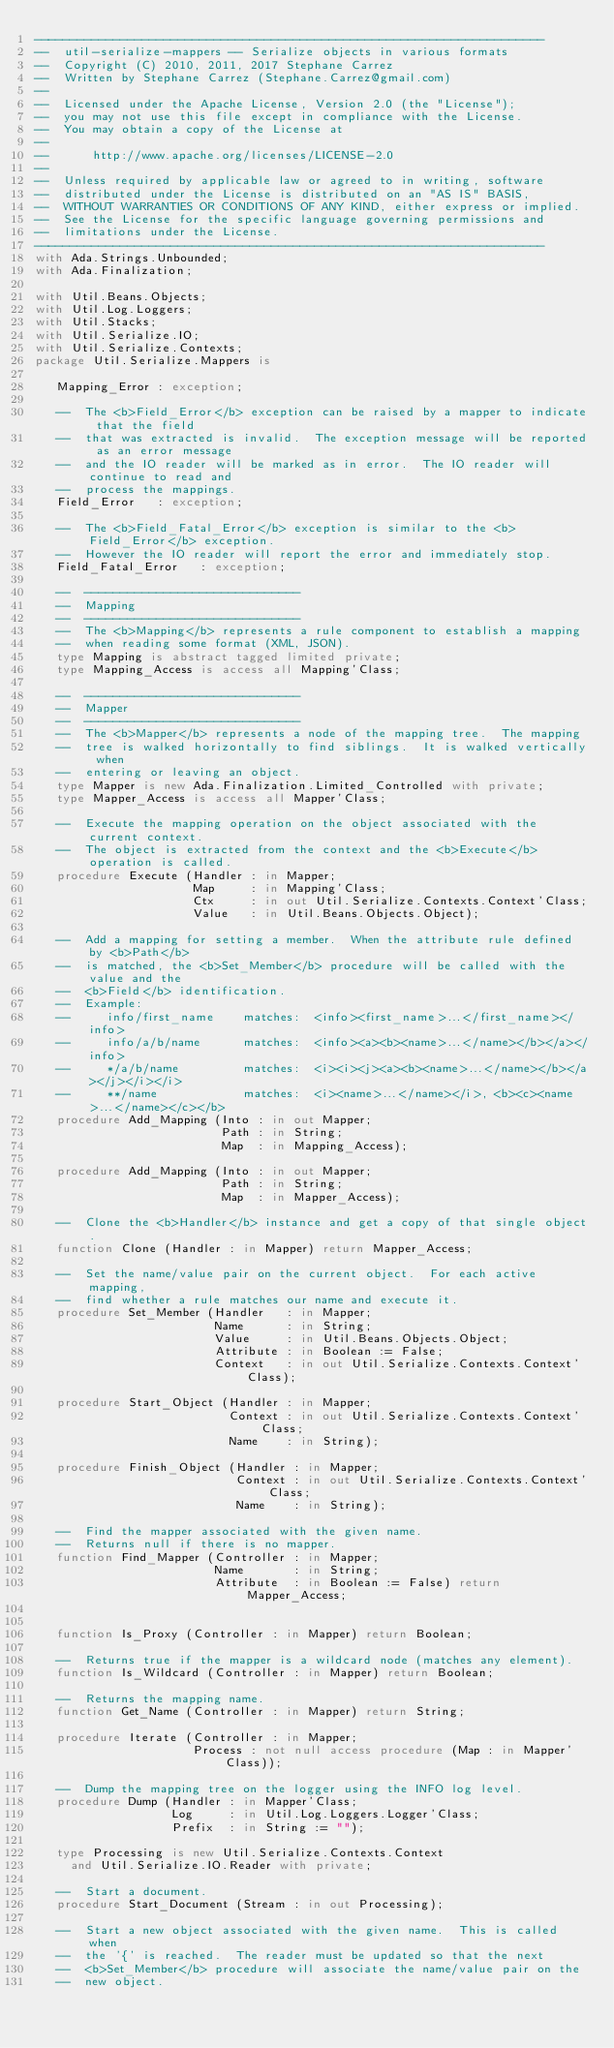<code> <loc_0><loc_0><loc_500><loc_500><_Ada_>-----------------------------------------------------------------------
--  util-serialize-mappers -- Serialize objects in various formats
--  Copyright (C) 2010, 2011, 2017 Stephane Carrez
--  Written by Stephane Carrez (Stephane.Carrez@gmail.com)
--
--  Licensed under the Apache License, Version 2.0 (the "License");
--  you may not use this file except in compliance with the License.
--  You may obtain a copy of the License at
--
--      http://www.apache.org/licenses/LICENSE-2.0
--
--  Unless required by applicable law or agreed to in writing, software
--  distributed under the License is distributed on an "AS IS" BASIS,
--  WITHOUT WARRANTIES OR CONDITIONS OF ANY KIND, either express or implied.
--  See the License for the specific language governing permissions and
--  limitations under the License.
-----------------------------------------------------------------------
with Ada.Strings.Unbounded;
with Ada.Finalization;

with Util.Beans.Objects;
with Util.Log.Loggers;
with Util.Stacks;
with Util.Serialize.IO;
with Util.Serialize.Contexts;
package Util.Serialize.Mappers is

   Mapping_Error : exception;

   --  The <b>Field_Error</b> exception can be raised by a mapper to indicate that the field
   --  that was extracted is invalid.  The exception message will be reported as an error message
   --  and the IO reader will be marked as in error.  The IO reader will continue to read and
   --  process the mappings.
   Field_Error   : exception;

   --  The <b>Field_Fatal_Error</b> exception is similar to the <b>Field_Error</b> exception.
   --  However the IO reader will report the error and immediately stop.
   Field_Fatal_Error   : exception;

   --  ------------------------------
   --  Mapping
   --  ------------------------------
   --  The <b>Mapping</b> represents a rule component to establish a mapping
   --  when reading some format (XML, JSON).
   type Mapping is abstract tagged limited private;
   type Mapping_Access is access all Mapping'Class;

   --  ------------------------------
   --  Mapper
   --  ------------------------------
   --  The <b>Mapper</b> represents a node of the mapping tree.  The mapping
   --  tree is walked horizontally to find siblings.  It is walked vertically when
   --  entering or leaving an object.
   type Mapper is new Ada.Finalization.Limited_Controlled with private;
   type Mapper_Access is access all Mapper'Class;

   --  Execute the mapping operation on the object associated with the current context.
   --  The object is extracted from the context and the <b>Execute</b> operation is called.
   procedure Execute (Handler : in Mapper;
                      Map     : in Mapping'Class;
                      Ctx     : in out Util.Serialize.Contexts.Context'Class;
                      Value   : in Util.Beans.Objects.Object);

   --  Add a mapping for setting a member.  When the attribute rule defined by <b>Path</b>
   --  is matched, the <b>Set_Member</b> procedure will be called with the value and the
   --  <b>Field</b> identification.
   --  Example:
   --     info/first_name    matches:  <info><first_name>...</first_name></info>
   --     info/a/b/name      matches:  <info><a><b><name>...</name></b></a></info>
   --     */a/b/name         matches:  <i><i><j><a><b><name>...</name></b></a></j></i></i>
   --     **/name            matches:  <i><name>...</name></i>, <b><c><name>...</name></c></b>
   procedure Add_Mapping (Into : in out Mapper;
                          Path : in String;
                          Map  : in Mapping_Access);

   procedure Add_Mapping (Into : in out Mapper;
                          Path : in String;
                          Map  : in Mapper_Access);

   --  Clone the <b>Handler</b> instance and get a copy of that single object.
   function Clone (Handler : in Mapper) return Mapper_Access;

   --  Set the name/value pair on the current object.  For each active mapping,
   --  find whether a rule matches our name and execute it.
   procedure Set_Member (Handler   : in Mapper;
                         Name      : in String;
                         Value     : in Util.Beans.Objects.Object;
                         Attribute : in Boolean := False;
                         Context   : in out Util.Serialize.Contexts.Context'Class);

   procedure Start_Object (Handler : in Mapper;
                           Context : in out Util.Serialize.Contexts.Context'Class;
                           Name    : in String);

   procedure Finish_Object (Handler : in Mapper;
                            Context : in out Util.Serialize.Contexts.Context'Class;
                            Name    : in String);

   --  Find the mapper associated with the given name.
   --  Returns null if there is no mapper.
   function Find_Mapper (Controller : in Mapper;
                         Name       : in String;
                         Attribute  : in Boolean := False) return Mapper_Access;


   function Is_Proxy (Controller : in Mapper) return Boolean;

   --  Returns true if the mapper is a wildcard node (matches any element).
   function Is_Wildcard (Controller : in Mapper) return Boolean;

   --  Returns the mapping name.
   function Get_Name (Controller : in Mapper) return String;

   procedure Iterate (Controller : in Mapper;
                      Process : not null access procedure (Map : in Mapper'Class));

   --  Dump the mapping tree on the logger using the INFO log level.
   procedure Dump (Handler : in Mapper'Class;
                   Log     : in Util.Log.Loggers.Logger'Class;
                   Prefix  : in String := "");

   type Processing is new Util.Serialize.Contexts.Context
     and Util.Serialize.IO.Reader with private;

   --  Start a document.
   procedure Start_Document (Stream : in out Processing);

   --  Start a new object associated with the given name.  This is called when
   --  the '{' is reached.  The reader must be updated so that the next
   --  <b>Set_Member</b> procedure will associate the name/value pair on the
   --  new object.</code> 